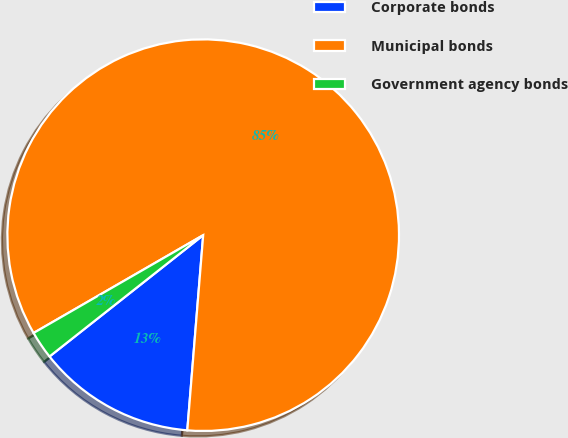Convert chart. <chart><loc_0><loc_0><loc_500><loc_500><pie_chart><fcel>Corporate bonds<fcel>Municipal bonds<fcel>Government agency bonds<nl><fcel>13.07%<fcel>84.62%<fcel>2.31%<nl></chart> 